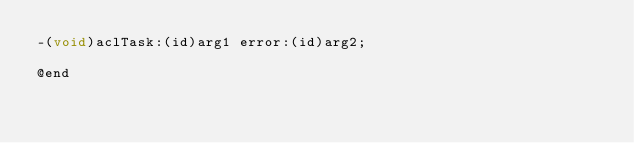Convert code to text. <code><loc_0><loc_0><loc_500><loc_500><_C_>-(void)aclTask:(id)arg1 error:(id)arg2;

@end

</code> 